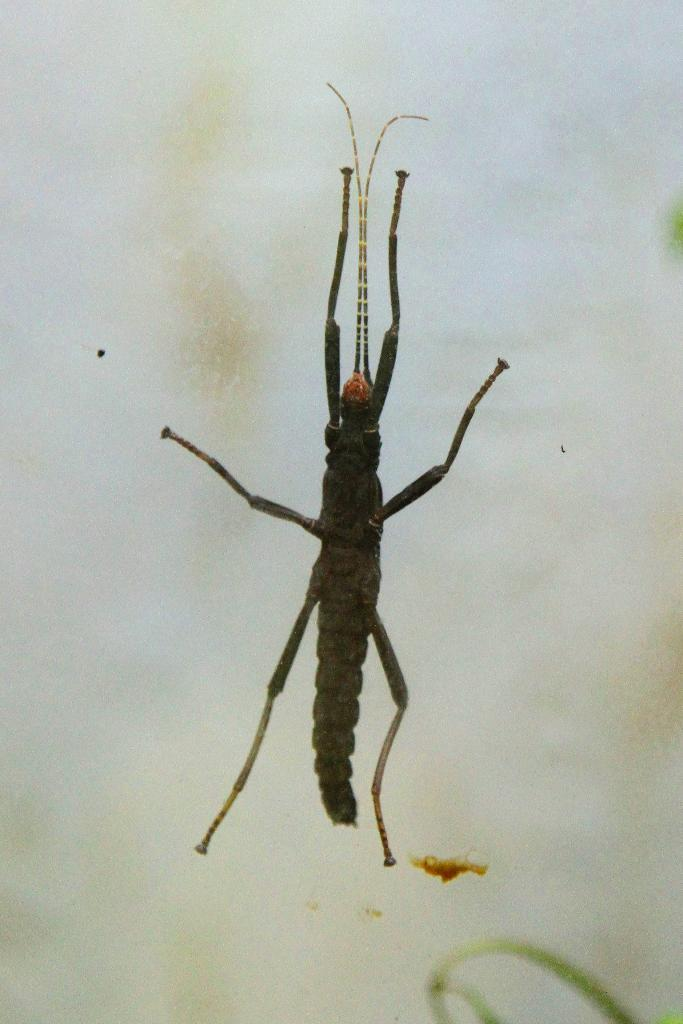What type of creature is present in the image? There is an insect in the image. What is the color of the insect? The insect is black in color. What is the background or surface on which the insect is located? The insect is on a white surface. Can you see a plane flying in the background of the image? There is no plane visible in the image; it only features an insect on a white surface. Is there a laborer working on the white surface in the image? There is no laborer present in the image; it only features an insect on a white surface. 